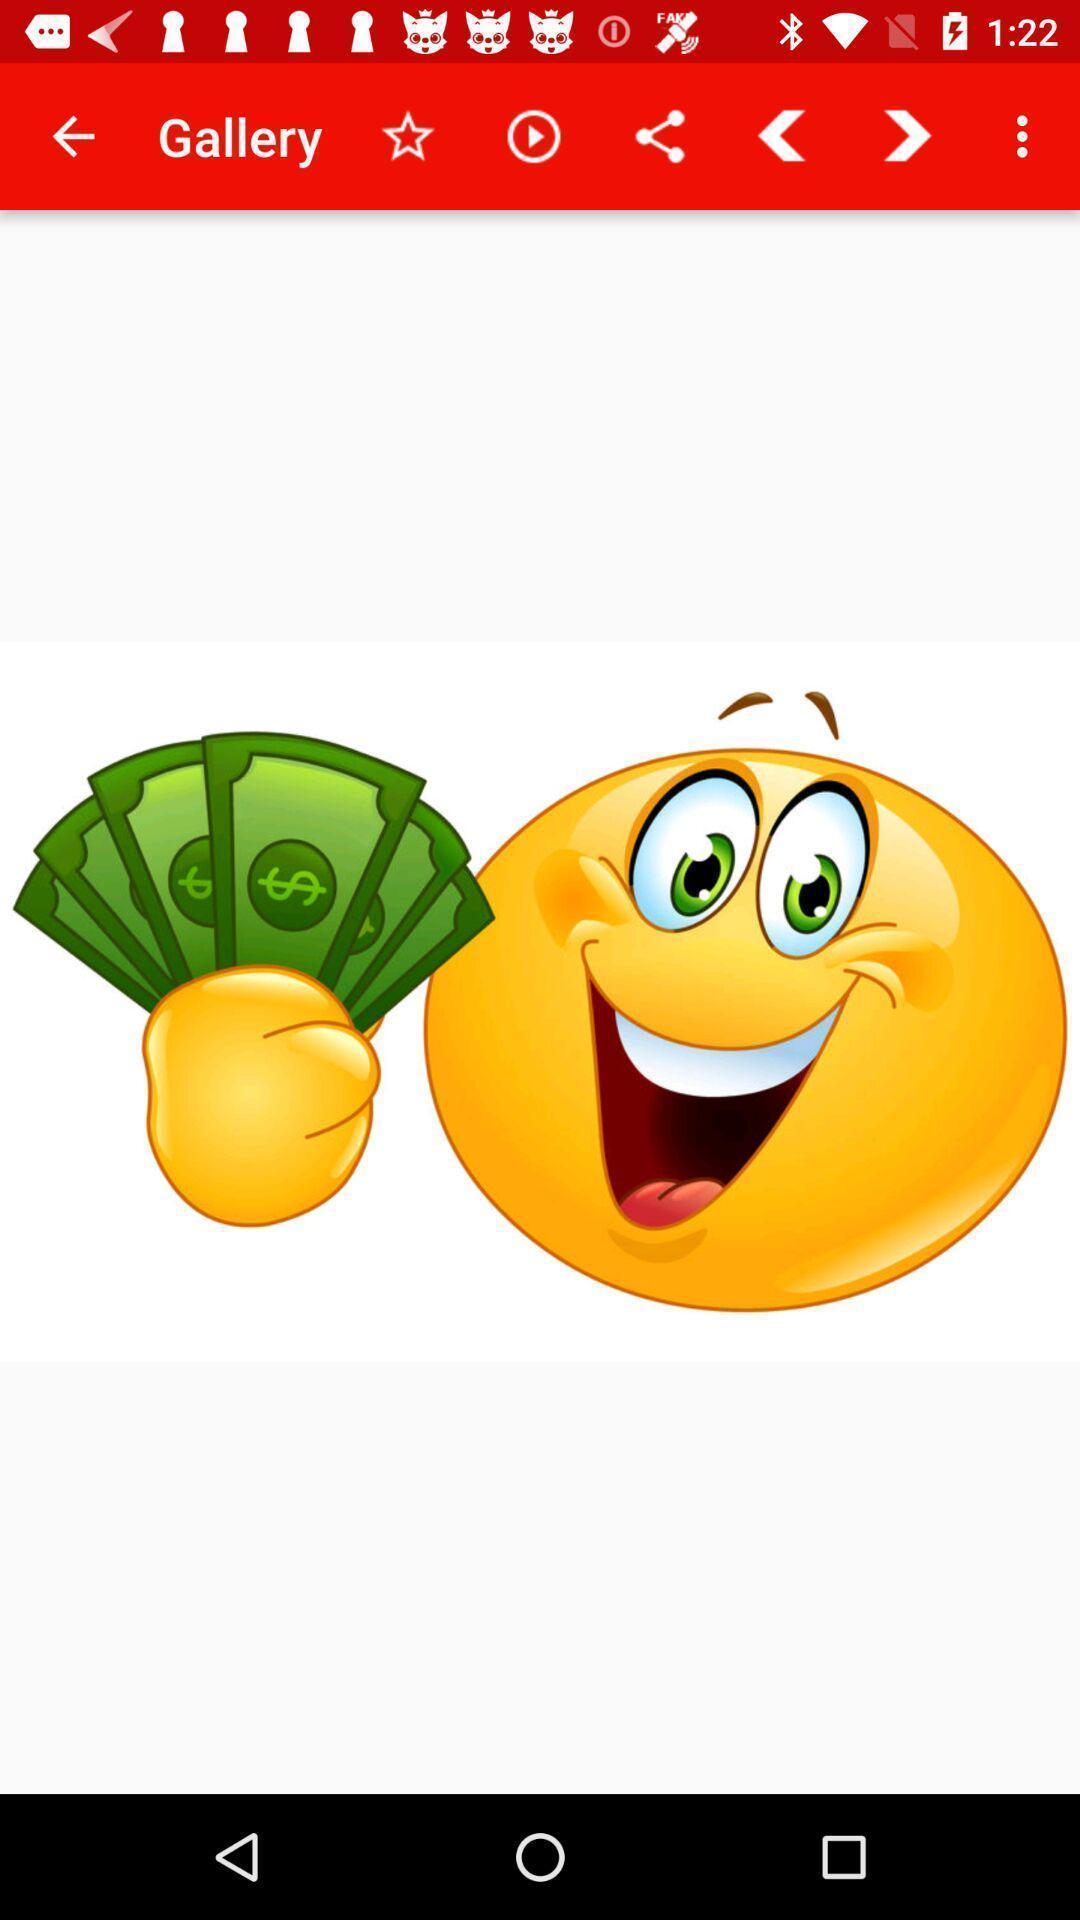Summarize the information in this screenshot. Page showing images in gallery. 